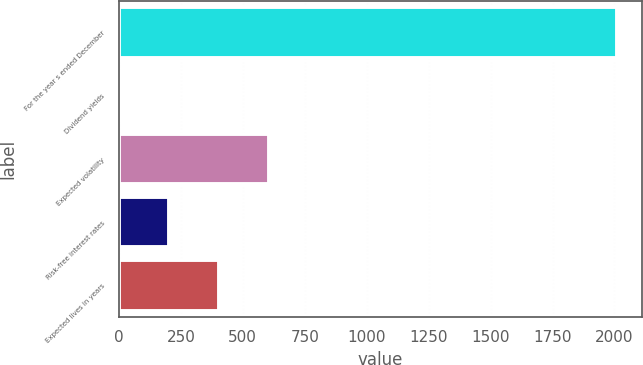Convert chart to OTSL. <chart><loc_0><loc_0><loc_500><loc_500><bar_chart><fcel>For the year s ended December<fcel>Dividend yields<fcel>Expected volatility<fcel>Risk-free interest rates<fcel>Expected lives in years<nl><fcel>2011<fcel>2.7<fcel>605.19<fcel>203.53<fcel>404.36<nl></chart> 